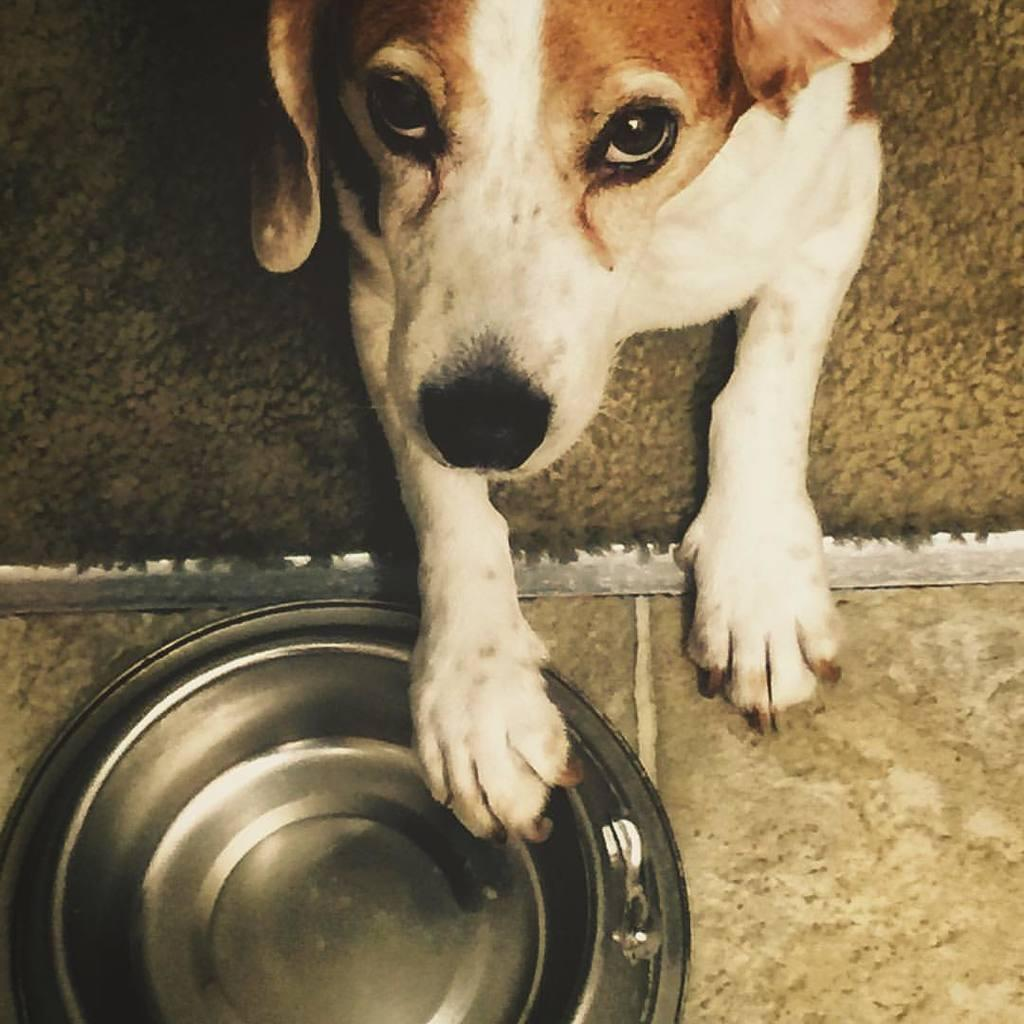What is the main subject in the center of the image? There is a dog in the center of the image. What is located at the bottom of the image? There is a bowl at the bottom of the image. What type of surface is visible in the background of the image? There is a floor visible in the background of the image. What type of floor covering is present in the background of the image? There is a carpet in the background of the image. How many cows can be seen grazing on the land in the image? There are no cows or land visible in the image; it features a dog, a bowl, and a carpeted floor. What type of bird is perched on the robin in the image? There is no robin present in the image; it features a dog, a bowl, and a carpeted floor. 